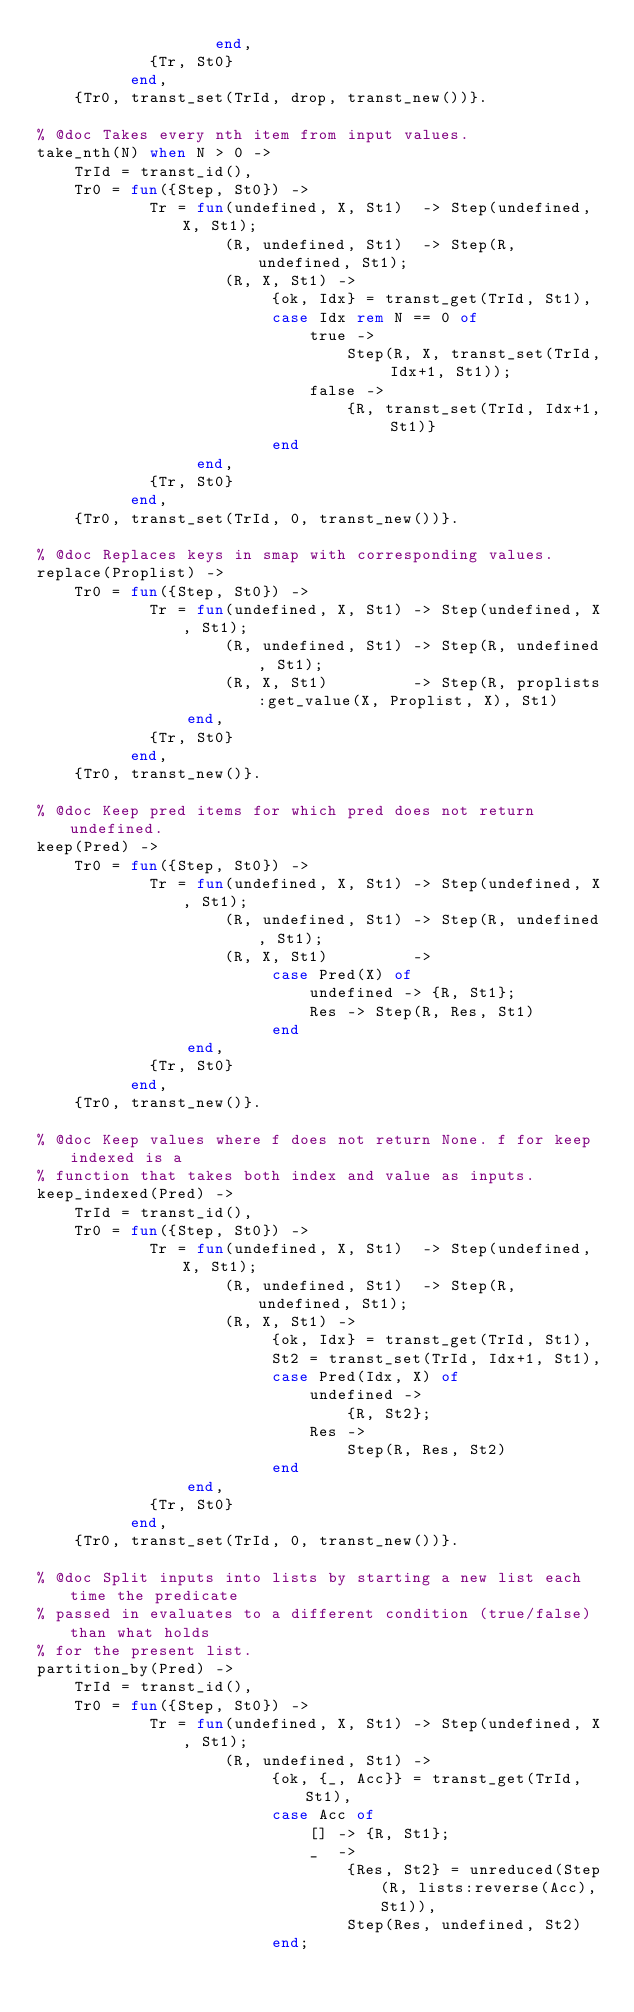<code> <loc_0><loc_0><loc_500><loc_500><_Erlang_>                   end,
            {Tr, St0}
          end,
    {Tr0, transt_set(TrId, drop, transt_new())}.

% @doc Takes every nth item from input values.
take_nth(N) when N > 0 ->
    TrId = transt_id(),
    Tr0 = fun({Step, St0}) ->
            Tr = fun(undefined, X, St1)  -> Step(undefined, X, St1);
                    (R, undefined, St1)  -> Step(R, undefined, St1);
                    (R, X, St1) ->
                         {ok, Idx} = transt_get(TrId, St1),
                         case Idx rem N == 0 of
                             true ->
                                 Step(R, X, transt_set(TrId, Idx+1, St1));
                             false ->
                                 {R, transt_set(TrId, Idx+1, St1)}
                         end
                 end,
            {Tr, St0}
          end,
    {Tr0, transt_set(TrId, 0, transt_new())}.

% @doc Replaces keys in smap with corresponding values.
replace(Proplist) ->
    Tr0 = fun({Step, St0}) ->
            Tr = fun(undefined, X, St1) -> Step(undefined, X, St1);
                    (R, undefined, St1) -> Step(R, undefined, St1);
                    (R, X, St1)         -> Step(R, proplists:get_value(X, Proplist, X), St1)
                end,
            {Tr, St0}
          end,
    {Tr0, transt_new()}.

% @doc Keep pred items for which pred does not return undefined.
keep(Pred) ->
    Tr0 = fun({Step, St0}) ->
            Tr = fun(undefined, X, St1) -> Step(undefined, X, St1);
                    (R, undefined, St1) -> Step(R, undefined, St1);
                    (R, X, St1)         ->
                         case Pred(X) of
                             undefined -> {R, St1};
                             Res -> Step(R, Res, St1)
                         end
                end,
            {Tr, St0}
          end,
    {Tr0, transt_new()}.

% @doc Keep values where f does not return None. f for keep indexed is a
% function that takes both index and value as inputs.
keep_indexed(Pred) ->
    TrId = transt_id(),
    Tr0 = fun({Step, St0}) ->
            Tr = fun(undefined, X, St1)  -> Step(undefined, X, St1);
                    (R, undefined, St1)  -> Step(R, undefined, St1);
                    (R, X, St1) ->
                         {ok, Idx} = transt_get(TrId, St1),
                         St2 = transt_set(TrId, Idx+1, St1),
                         case Pred(Idx, X) of
                             undefined ->
                                 {R, St2};
                             Res ->
                                 Step(R, Res, St2)
                         end
                end,
            {Tr, St0}
          end,
    {Tr0, transt_set(TrId, 0, transt_new())}.

% @doc Split inputs into lists by starting a new list each time the predicate
% passed in evaluates to a different condition (true/false) than what holds
% for the present list.
partition_by(Pred) ->
    TrId = transt_id(),
    Tr0 = fun({Step, St0}) ->
            Tr = fun(undefined, X, St1) -> Step(undefined, X, St1);
                    (R, undefined, St1) ->
                         {ok, {_, Acc}} = transt_get(TrId, St1),
                         case Acc of
                             [] -> {R, St1};
                             _  ->
                                 {Res, St2} = unreduced(Step(R, lists:reverse(Acc), St1)),
                                 Step(Res, undefined, St2)
                         end;</code> 